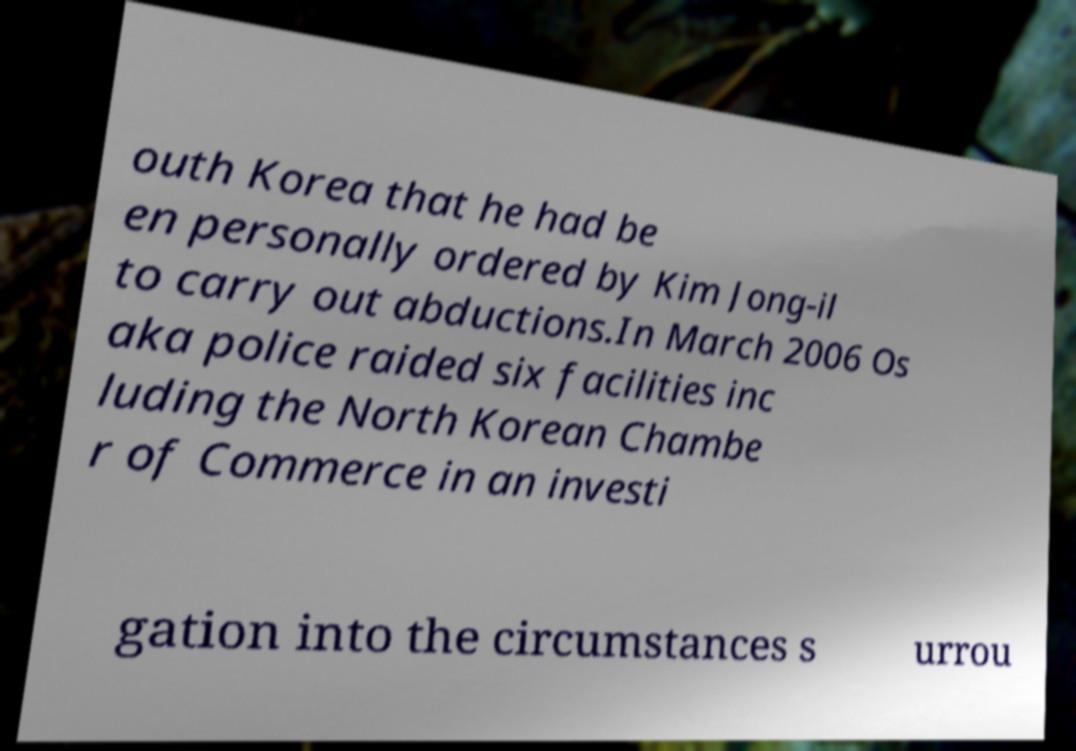For documentation purposes, I need the text within this image transcribed. Could you provide that? outh Korea that he had be en personally ordered by Kim Jong-il to carry out abductions.In March 2006 Os aka police raided six facilities inc luding the North Korean Chambe r of Commerce in an investi gation into the circumstances s urrou 